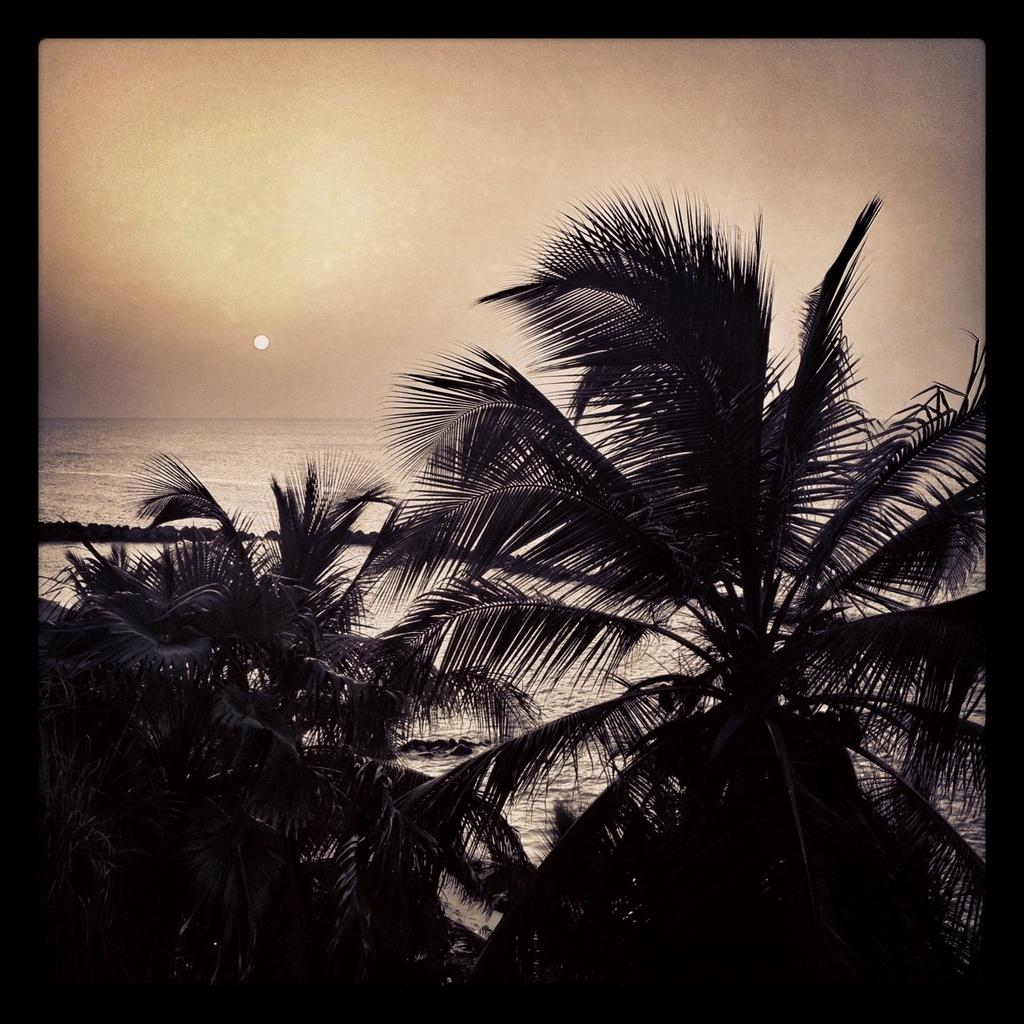What can be seen in the background of the image? The sky and the sun are visible in the background of the image. What type of vegetation is present in the image? There are trees in the image. What natural feature is depicted in the image? There is a sea in the image. What color is used for the borders of the image? The borders of the image are in black color. What advice does the grandfather give to the person in the image? There is no person or grandfather present in the image, so it is not possible to answer that question. 